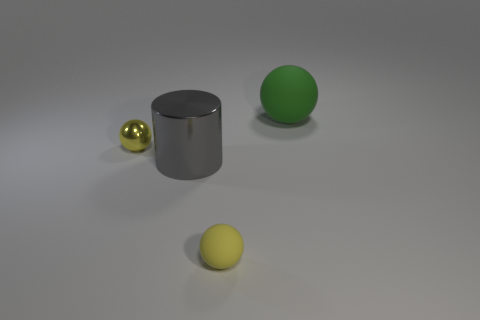Subtract all matte balls. How many balls are left? 1 Add 1 small rubber spheres. How many objects exist? 5 Subtract all green blocks. How many cyan spheres are left? 0 Subtract all big purple rubber cylinders. Subtract all small yellow metallic things. How many objects are left? 3 Add 3 large cylinders. How many large cylinders are left? 4 Add 1 green spheres. How many green spheres exist? 2 Subtract all green spheres. How many spheres are left? 2 Subtract 0 blue cubes. How many objects are left? 4 Subtract all cylinders. How many objects are left? 3 Subtract 2 spheres. How many spheres are left? 1 